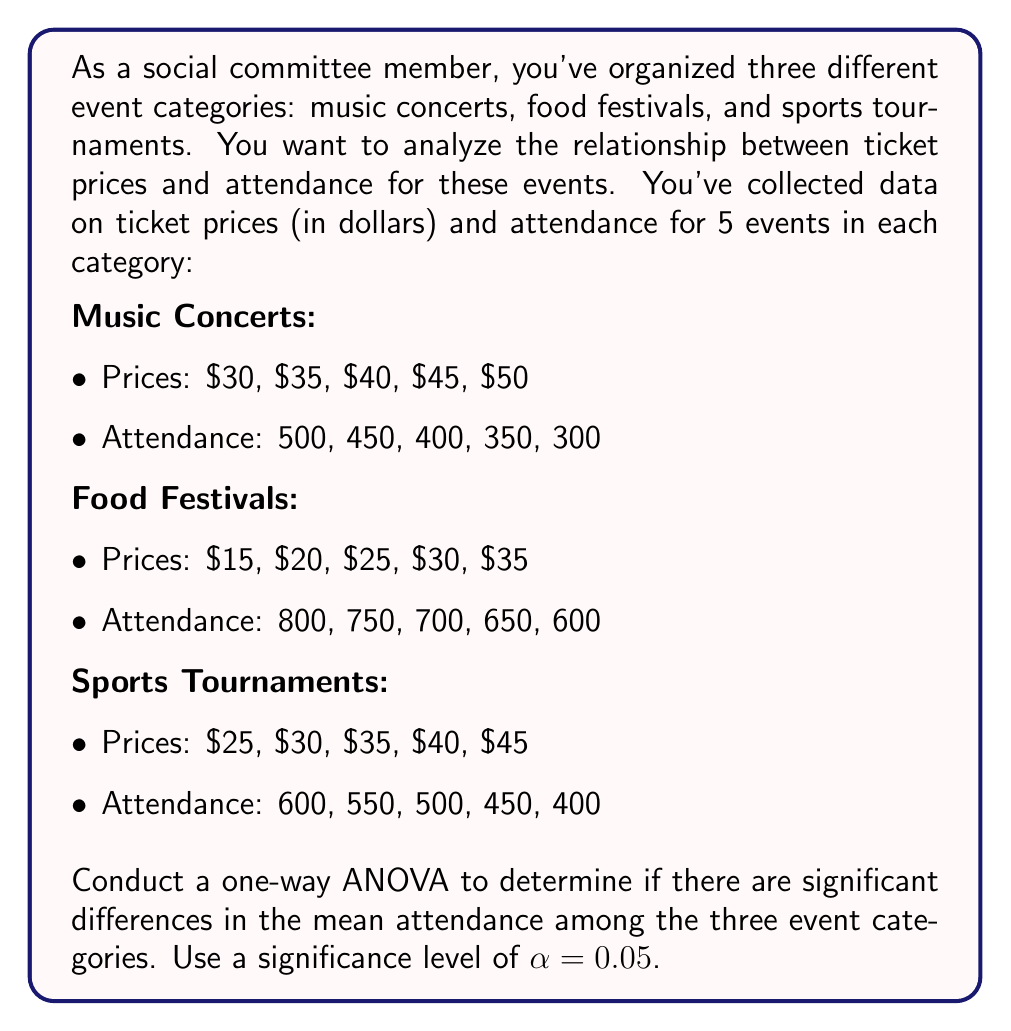Provide a solution to this math problem. To conduct a one-way ANOVA, we'll follow these steps:

1. Calculate the sum of squares between groups (SSB), sum of squares within groups (SSW), and total sum of squares (SST).
2. Calculate the degrees of freedom for between groups (dfB), within groups (dfW), and total (dfT).
3. Calculate the mean square between groups (MSB) and mean square within groups (MSW).
4. Calculate the F-statistic.
5. Compare the F-statistic to the critical F-value.

Step 1: Calculate SS

First, we need to calculate the grand mean of attendance:
$$\bar{X} = \frac{(500+450+400+350+300)+(800+750+700+650+600)+(600+550+500+450+400)}{15} = 533.33$$

Now, we can calculate SSB, SSW, and SST:

SSB:
$$SSB = 5[(400-533.33)^2 + (700-533.33)^2 + (500-533.33)^2] = 450,000$$

SSW:
$$SSW = [(500-400)^2 + (450-400)^2 + (400-400)^2 + (350-400)^2 + (300-400)^2] + $$
$$[(800-700)^2 + (750-700)^2 + (700-700)^2 + (650-700)^2 + (600-700)^2] + $$
$$[(600-500)^2 + (550-500)^2 + (500-500)^2 + (450-500)^2 + (400-500)^2] = 150,000$$

SST:
$$SST = SSB + SSW = 450,000 + 150,000 = 600,000$$

Step 2: Calculate degrees of freedom

$$dfB = k - 1 = 3 - 1 = 2$$
$$dfW = N - k = 15 - 3 = 12$$
$$dfT = N - 1 = 15 - 1 = 14$$

Where k is the number of groups and N is the total number of observations.

Step 3: Calculate mean squares

$$MSB = \frac{SSB}{dfB} = \frac{450,000}{2} = 225,000$$
$$MSW = \frac{SSW}{dfW} = \frac{150,000}{12} = 12,500$$

Step 4: Calculate F-statistic

$$F = \frac{MSB}{MSW} = \frac{225,000}{12,500} = 18$$

Step 5: Compare F-statistic to critical F-value

The critical F-value for $\alpha = 0.05$, $dfB = 2$, and $dfW = 12$ is approximately 3.89.

Since our calculated F-statistic (18) is greater than the critical F-value (3.89), we reject the null hypothesis.
Answer: The one-way ANOVA results show a significant difference in mean attendance among the three event categories (F(2,12) = 18, p < 0.05). We reject the null hypothesis and conclude that there are significant differences in attendance between music concerts, food festivals, and sports tournaments. 